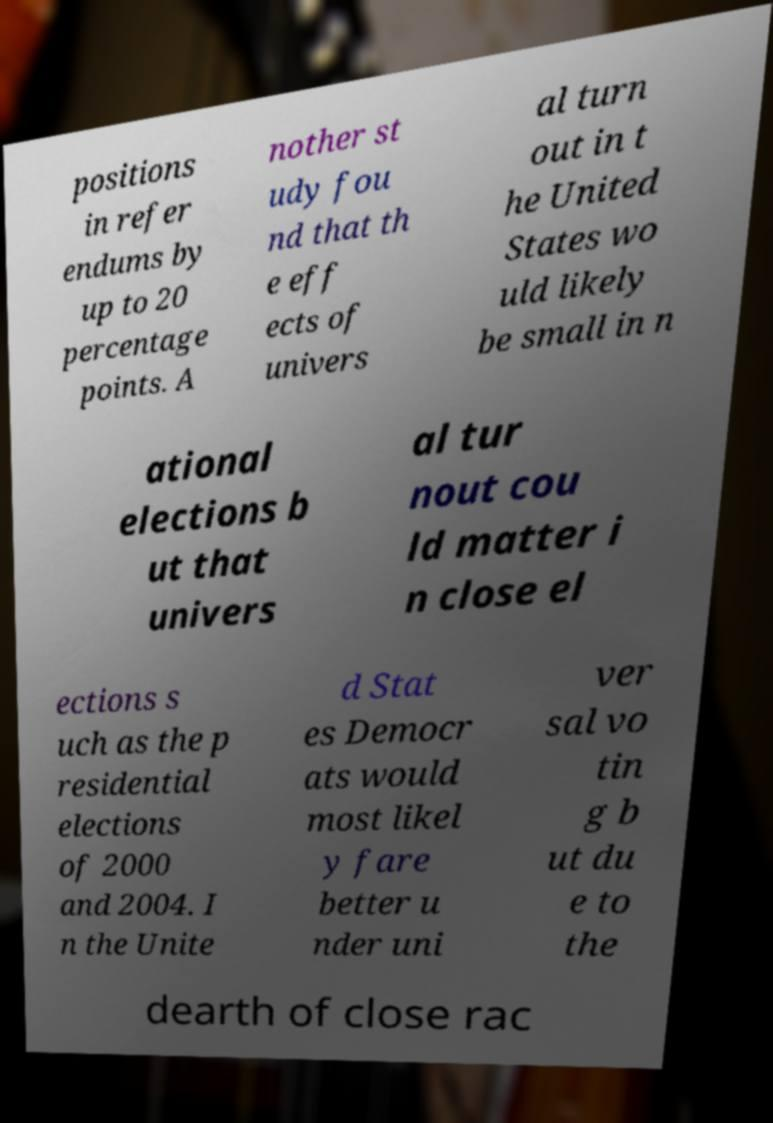There's text embedded in this image that I need extracted. Can you transcribe it verbatim? positions in refer endums by up to 20 percentage points. A nother st udy fou nd that th e eff ects of univers al turn out in t he United States wo uld likely be small in n ational elections b ut that univers al tur nout cou ld matter i n close el ections s uch as the p residential elections of 2000 and 2004. I n the Unite d Stat es Democr ats would most likel y fare better u nder uni ver sal vo tin g b ut du e to the dearth of close rac 